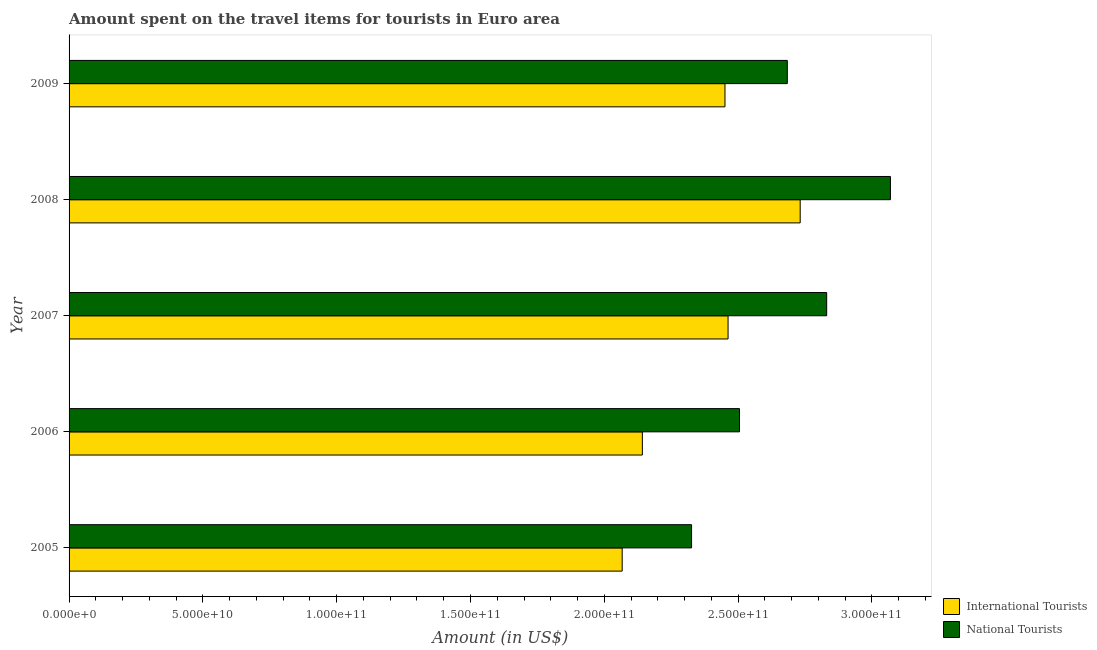Are the number of bars per tick equal to the number of legend labels?
Provide a short and direct response. Yes. Are the number of bars on each tick of the Y-axis equal?
Provide a short and direct response. Yes. What is the label of the 1st group of bars from the top?
Offer a very short reply. 2009. In how many cases, is the number of bars for a given year not equal to the number of legend labels?
Your answer should be very brief. 0. What is the amount spent on travel items of international tourists in 2008?
Keep it short and to the point. 2.73e+11. Across all years, what is the maximum amount spent on travel items of national tourists?
Offer a very short reply. 3.07e+11. Across all years, what is the minimum amount spent on travel items of international tourists?
Keep it short and to the point. 2.07e+11. In which year was the amount spent on travel items of national tourists maximum?
Keep it short and to the point. 2008. What is the total amount spent on travel items of international tourists in the graph?
Give a very brief answer. 1.19e+12. What is the difference between the amount spent on travel items of national tourists in 2005 and that in 2008?
Provide a short and direct response. -7.43e+1. What is the difference between the amount spent on travel items of international tourists in 2009 and the amount spent on travel items of national tourists in 2005?
Provide a succinct answer. 1.25e+1. What is the average amount spent on travel items of national tourists per year?
Provide a succinct answer. 2.68e+11. In the year 2005, what is the difference between the amount spent on travel items of national tourists and amount spent on travel items of international tourists?
Your response must be concise. 2.59e+1. What is the ratio of the amount spent on travel items of international tourists in 2006 to that in 2009?
Your response must be concise. 0.87. Is the amount spent on travel items of national tourists in 2006 less than that in 2008?
Ensure brevity in your answer.  Yes. What is the difference between the highest and the second highest amount spent on travel items of international tourists?
Offer a terse response. 2.70e+1. What is the difference between the highest and the lowest amount spent on travel items of national tourists?
Provide a short and direct response. 7.43e+1. What does the 2nd bar from the top in 2008 represents?
Give a very brief answer. International Tourists. What does the 1st bar from the bottom in 2009 represents?
Offer a terse response. International Tourists. How many bars are there?
Provide a short and direct response. 10. How many years are there in the graph?
Offer a terse response. 5. Does the graph contain any zero values?
Your answer should be compact. No. Does the graph contain grids?
Ensure brevity in your answer.  No. How many legend labels are there?
Offer a terse response. 2. What is the title of the graph?
Your answer should be compact. Amount spent on the travel items for tourists in Euro area. Does "GDP at market prices" appear as one of the legend labels in the graph?
Ensure brevity in your answer.  No. What is the label or title of the X-axis?
Your response must be concise. Amount (in US$). What is the label or title of the Y-axis?
Ensure brevity in your answer.  Year. What is the Amount (in US$) of International Tourists in 2005?
Provide a short and direct response. 2.07e+11. What is the Amount (in US$) of National Tourists in 2005?
Offer a very short reply. 2.33e+11. What is the Amount (in US$) of International Tourists in 2006?
Your response must be concise. 2.14e+11. What is the Amount (in US$) of National Tourists in 2006?
Your response must be concise. 2.51e+11. What is the Amount (in US$) of International Tourists in 2007?
Provide a short and direct response. 2.46e+11. What is the Amount (in US$) of National Tourists in 2007?
Your answer should be very brief. 2.83e+11. What is the Amount (in US$) in International Tourists in 2008?
Give a very brief answer. 2.73e+11. What is the Amount (in US$) in National Tourists in 2008?
Offer a very short reply. 3.07e+11. What is the Amount (in US$) of International Tourists in 2009?
Your answer should be very brief. 2.45e+11. What is the Amount (in US$) in National Tourists in 2009?
Your answer should be compact. 2.68e+11. Across all years, what is the maximum Amount (in US$) in International Tourists?
Offer a terse response. 2.73e+11. Across all years, what is the maximum Amount (in US$) in National Tourists?
Offer a very short reply. 3.07e+11. Across all years, what is the minimum Amount (in US$) of International Tourists?
Keep it short and to the point. 2.07e+11. Across all years, what is the minimum Amount (in US$) of National Tourists?
Your answer should be very brief. 2.33e+11. What is the total Amount (in US$) of International Tourists in the graph?
Offer a very short reply. 1.19e+12. What is the total Amount (in US$) of National Tourists in the graph?
Give a very brief answer. 1.34e+12. What is the difference between the Amount (in US$) of International Tourists in 2005 and that in 2006?
Provide a succinct answer. -7.54e+09. What is the difference between the Amount (in US$) of National Tourists in 2005 and that in 2006?
Offer a terse response. -1.79e+1. What is the difference between the Amount (in US$) in International Tourists in 2005 and that in 2007?
Ensure brevity in your answer.  -3.96e+1. What is the difference between the Amount (in US$) of National Tourists in 2005 and that in 2007?
Your response must be concise. -5.05e+1. What is the difference between the Amount (in US$) in International Tourists in 2005 and that in 2008?
Make the answer very short. -6.65e+1. What is the difference between the Amount (in US$) in National Tourists in 2005 and that in 2008?
Your answer should be very brief. -7.43e+1. What is the difference between the Amount (in US$) in International Tourists in 2005 and that in 2009?
Offer a very short reply. -3.84e+1. What is the difference between the Amount (in US$) in National Tourists in 2005 and that in 2009?
Your answer should be very brief. -3.58e+1. What is the difference between the Amount (in US$) in International Tourists in 2006 and that in 2007?
Your answer should be compact. -3.20e+1. What is the difference between the Amount (in US$) in National Tourists in 2006 and that in 2007?
Offer a terse response. -3.26e+1. What is the difference between the Amount (in US$) of International Tourists in 2006 and that in 2008?
Provide a succinct answer. -5.90e+1. What is the difference between the Amount (in US$) of National Tourists in 2006 and that in 2008?
Offer a very short reply. -5.64e+1. What is the difference between the Amount (in US$) of International Tourists in 2006 and that in 2009?
Your answer should be compact. -3.09e+1. What is the difference between the Amount (in US$) in National Tourists in 2006 and that in 2009?
Your answer should be compact. -1.79e+1. What is the difference between the Amount (in US$) in International Tourists in 2007 and that in 2008?
Your response must be concise. -2.70e+1. What is the difference between the Amount (in US$) in National Tourists in 2007 and that in 2008?
Ensure brevity in your answer.  -2.38e+1. What is the difference between the Amount (in US$) in International Tourists in 2007 and that in 2009?
Offer a very short reply. 1.16e+09. What is the difference between the Amount (in US$) of National Tourists in 2007 and that in 2009?
Provide a succinct answer. 1.47e+1. What is the difference between the Amount (in US$) of International Tourists in 2008 and that in 2009?
Your response must be concise. 2.81e+1. What is the difference between the Amount (in US$) in National Tourists in 2008 and that in 2009?
Ensure brevity in your answer.  3.85e+1. What is the difference between the Amount (in US$) in International Tourists in 2005 and the Amount (in US$) in National Tourists in 2006?
Provide a succinct answer. -4.38e+1. What is the difference between the Amount (in US$) of International Tourists in 2005 and the Amount (in US$) of National Tourists in 2007?
Offer a terse response. -7.64e+1. What is the difference between the Amount (in US$) of International Tourists in 2005 and the Amount (in US$) of National Tourists in 2008?
Your answer should be compact. -1.00e+11. What is the difference between the Amount (in US$) in International Tourists in 2005 and the Amount (in US$) in National Tourists in 2009?
Provide a short and direct response. -6.17e+1. What is the difference between the Amount (in US$) of International Tourists in 2006 and the Amount (in US$) of National Tourists in 2007?
Your answer should be very brief. -6.89e+1. What is the difference between the Amount (in US$) of International Tourists in 2006 and the Amount (in US$) of National Tourists in 2008?
Your answer should be compact. -9.27e+1. What is the difference between the Amount (in US$) of International Tourists in 2006 and the Amount (in US$) of National Tourists in 2009?
Offer a very short reply. -5.42e+1. What is the difference between the Amount (in US$) of International Tourists in 2007 and the Amount (in US$) of National Tourists in 2008?
Keep it short and to the point. -6.07e+1. What is the difference between the Amount (in US$) in International Tourists in 2007 and the Amount (in US$) in National Tourists in 2009?
Make the answer very short. -2.21e+1. What is the difference between the Amount (in US$) in International Tourists in 2008 and the Amount (in US$) in National Tourists in 2009?
Provide a short and direct response. 4.81e+09. What is the average Amount (in US$) of International Tourists per year?
Your response must be concise. 2.37e+11. What is the average Amount (in US$) of National Tourists per year?
Ensure brevity in your answer.  2.68e+11. In the year 2005, what is the difference between the Amount (in US$) of International Tourists and Amount (in US$) of National Tourists?
Offer a terse response. -2.59e+1. In the year 2006, what is the difference between the Amount (in US$) in International Tourists and Amount (in US$) in National Tourists?
Give a very brief answer. -3.63e+1. In the year 2007, what is the difference between the Amount (in US$) in International Tourists and Amount (in US$) in National Tourists?
Ensure brevity in your answer.  -3.69e+1. In the year 2008, what is the difference between the Amount (in US$) in International Tourists and Amount (in US$) in National Tourists?
Your answer should be very brief. -3.37e+1. In the year 2009, what is the difference between the Amount (in US$) in International Tourists and Amount (in US$) in National Tourists?
Ensure brevity in your answer.  -2.33e+1. What is the ratio of the Amount (in US$) of International Tourists in 2005 to that in 2006?
Ensure brevity in your answer.  0.96. What is the ratio of the Amount (in US$) of National Tourists in 2005 to that in 2006?
Provide a short and direct response. 0.93. What is the ratio of the Amount (in US$) of International Tourists in 2005 to that in 2007?
Your answer should be compact. 0.84. What is the ratio of the Amount (in US$) in National Tourists in 2005 to that in 2007?
Provide a succinct answer. 0.82. What is the ratio of the Amount (in US$) of International Tourists in 2005 to that in 2008?
Ensure brevity in your answer.  0.76. What is the ratio of the Amount (in US$) of National Tourists in 2005 to that in 2008?
Offer a terse response. 0.76. What is the ratio of the Amount (in US$) in International Tourists in 2005 to that in 2009?
Give a very brief answer. 0.84. What is the ratio of the Amount (in US$) of National Tourists in 2005 to that in 2009?
Your answer should be very brief. 0.87. What is the ratio of the Amount (in US$) of International Tourists in 2006 to that in 2007?
Provide a succinct answer. 0.87. What is the ratio of the Amount (in US$) of National Tourists in 2006 to that in 2007?
Your answer should be very brief. 0.88. What is the ratio of the Amount (in US$) of International Tourists in 2006 to that in 2008?
Make the answer very short. 0.78. What is the ratio of the Amount (in US$) in National Tourists in 2006 to that in 2008?
Give a very brief answer. 0.82. What is the ratio of the Amount (in US$) in International Tourists in 2006 to that in 2009?
Provide a short and direct response. 0.87. What is the ratio of the Amount (in US$) of National Tourists in 2006 to that in 2009?
Provide a succinct answer. 0.93. What is the ratio of the Amount (in US$) of International Tourists in 2007 to that in 2008?
Offer a terse response. 0.9. What is the ratio of the Amount (in US$) in National Tourists in 2007 to that in 2008?
Provide a short and direct response. 0.92. What is the ratio of the Amount (in US$) in National Tourists in 2007 to that in 2009?
Offer a very short reply. 1.05. What is the ratio of the Amount (in US$) in International Tourists in 2008 to that in 2009?
Your response must be concise. 1.11. What is the ratio of the Amount (in US$) in National Tourists in 2008 to that in 2009?
Keep it short and to the point. 1.14. What is the difference between the highest and the second highest Amount (in US$) in International Tourists?
Make the answer very short. 2.70e+1. What is the difference between the highest and the second highest Amount (in US$) of National Tourists?
Offer a terse response. 2.38e+1. What is the difference between the highest and the lowest Amount (in US$) in International Tourists?
Provide a short and direct response. 6.65e+1. What is the difference between the highest and the lowest Amount (in US$) in National Tourists?
Provide a succinct answer. 7.43e+1. 